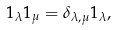<formula> <loc_0><loc_0><loc_500><loc_500>1 _ { \lambda } 1 _ { \mu } = \delta _ { \lambda , \mu } 1 _ { \lambda } ,</formula> 